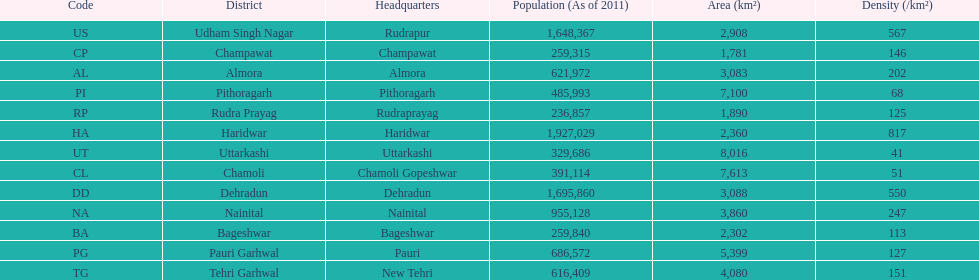Which has a larger population, dehradun or nainital? Dehradun. 